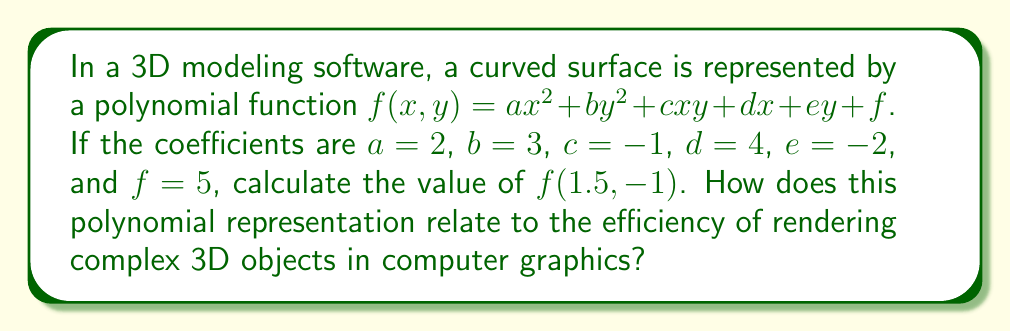Help me with this question. Let's approach this step-by-step:

1) We are given the polynomial function:
   $f(x,y) = ax^2 + by^2 + cxy + dx + ey + f$

2) And the coefficients:
   $a=2$, $b=3$, $c=-1$, $d=4$, $e=-2$, $f=5$

3) Substituting these into the function:
   $f(x,y) = 2x^2 + 3y^2 - xy + 4x - 2y + 5$

4) Now, we need to calculate $f(1.5, -1)$. Let's substitute $x=1.5$ and $y=-1$:
   $f(1.5, -1) = 2(1.5)^2 + 3(-1)^2 - (1.5)(-1) + 4(1.5) - 2(-1) + 5$

5) Let's calculate each term:
   - $2(1.5)^2 = 2(2.25) = 4.5$
   - $3(-1)^2 = 3(1) = 3$
   - $-(1.5)(-1) = 1.5$
   - $4(1.5) = 6$
   - $-2(-1) = 2$
   - $5$ remains as is

6) Sum all terms:
   $f(1.5, -1) = 4.5 + 3 + 1.5 + 6 + 2 + 5 = 22$

Regarding efficiency in 3D rendering:
Polynomial representations of surfaces, like the one used here, are computationally efficient for rendering. They allow complex curved surfaces to be described with relatively few parameters (the coefficients), which can be quickly evaluated at any point. This efficiency is crucial in real-time 3D graphics, where rapid calculations are necessary to render scenes at high frame rates. Moreover, these representations can be easily manipulated for operations like scaling, rotation, and deformation, which are common in 3D modeling and animation.
Answer: 22 